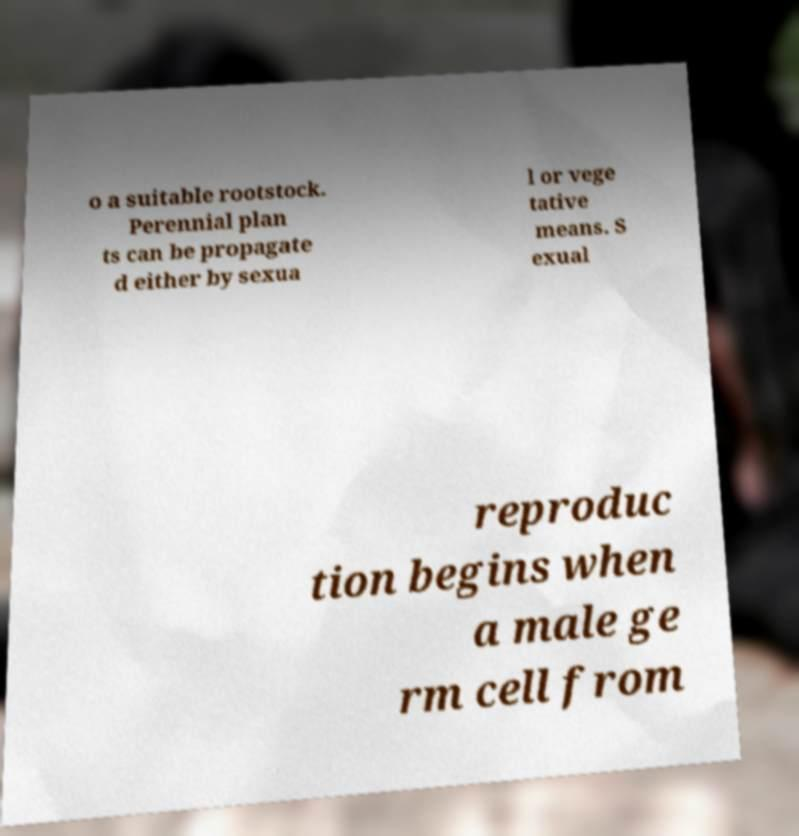Please identify and transcribe the text found in this image. o a suitable rootstock. Perennial plan ts can be propagate d either by sexua l or vege tative means. S exual reproduc tion begins when a male ge rm cell from 